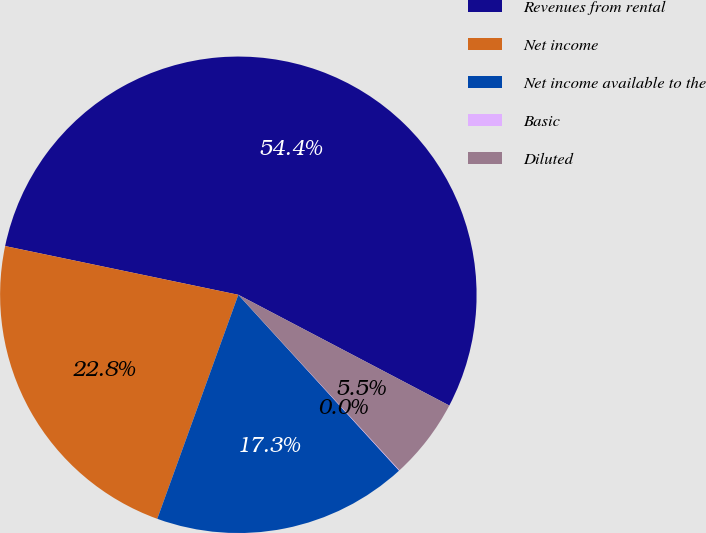<chart> <loc_0><loc_0><loc_500><loc_500><pie_chart><fcel>Revenues from rental<fcel>Net income<fcel>Net income available to the<fcel>Basic<fcel>Diluted<nl><fcel>54.41%<fcel>22.75%<fcel>17.31%<fcel>0.04%<fcel>5.48%<nl></chart> 